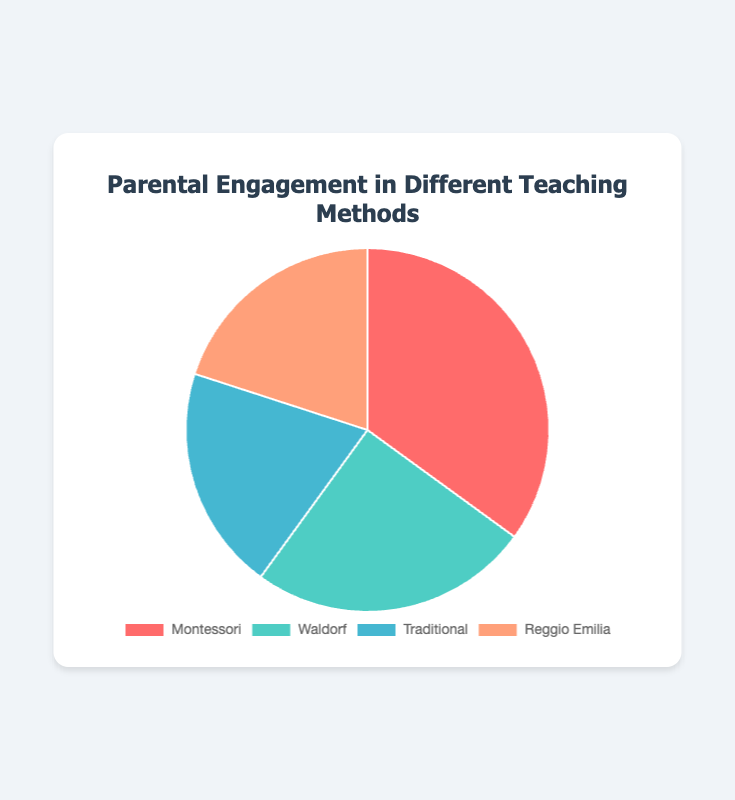What teaching method has the highest parental engagement? The slice with the largest percentage represents the teaching method with the highest parental engagement. In the pie chart, the largest slice, 35%, is labeled "Montessori".
Answer: Montessori What two teaching methods have the same level of parental engagement? Looking at the pie chart, the slices for "Traditional" and "Reggio Emilia" both represent 20% of parental engagement each.
Answer: Traditional and Reggio Emilia How much more parental engagement does Montessori have compared to Traditional? Montessori has 35% parental engagement, and Traditional has 20%. The difference is 35% - 20% = 15%.
Answer: 15% Which teaching method has the least amount of parental engagement? The smallest slices of the pie chart correspond to "Traditional" and "Reggio Emilia", each with 20% parental engagement. Therefore, both have the least amount.
Answer: Traditional and Reggio Emilia What is the total percentage of parental engagement for Montessori and Waldorf combined? Add the percentages of parental engagement for Montessori (35%) and Waldorf (25%). 35% + 25% = 60%.
Answer: 60% What percentage of parental engagement do Waldorf and Traditional methods have together? Add the percentages of parental engagement for Waldorf (25%) and Traditional (20%). 25% + 20% = 45%.
Answer: 45% Compare the parental engagement percentages of Waldorf and Reggio Emilia. Which one is greater? The pie chart shows Waldorf with 25% and Reggio Emilia with 20%. Thus, Waldorf's percentage is greater.
Answer: Waldorf How many teaching methods have a parental engagement percentage of 20% or higher? Montessori has 35%, Waldorf has 25%, Traditional has 20%, and Reggio Emilia also has 20%. Therefore, four methods have a parental engagement of 20% or higher.
Answer: 4 